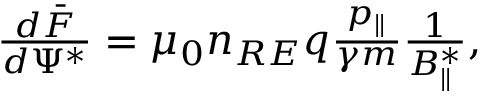<formula> <loc_0><loc_0><loc_500><loc_500>\begin{array} { r } { \frac { d \bar { F } } { d \Psi ^ { * } } = \mu _ { 0 } n _ { R E } q \frac { p _ { \| } } { \gamma m } \frac { 1 } { B _ { \| } ^ { * } } , } \end{array}</formula> 